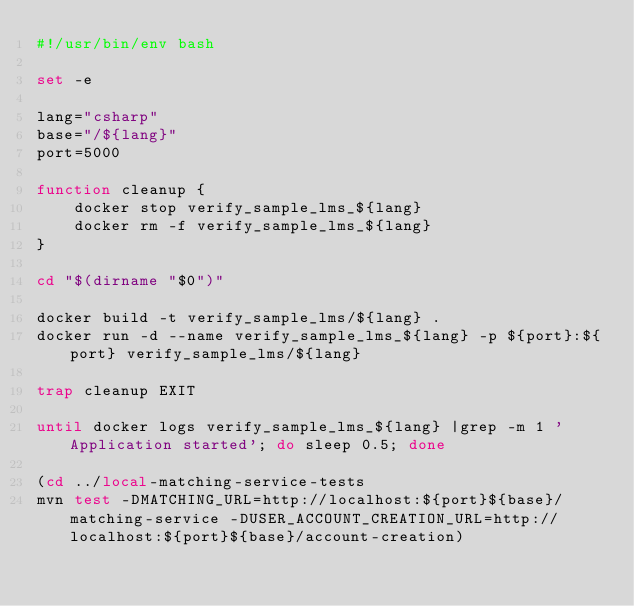Convert code to text. <code><loc_0><loc_0><loc_500><loc_500><_Bash_>#!/usr/bin/env bash

set -e

lang="csharp"
base="/${lang}"
port=5000

function cleanup {
    docker stop verify_sample_lms_${lang}
    docker rm -f verify_sample_lms_${lang}
}

cd "$(dirname "$0")"

docker build -t verify_sample_lms/${lang} .
docker run -d --name verify_sample_lms_${lang} -p ${port}:${port} verify_sample_lms/${lang}

trap cleanup EXIT

until docker logs verify_sample_lms_${lang} |grep -m 1 'Application started'; do sleep 0.5; done

(cd ../local-matching-service-tests
mvn test -DMATCHING_URL=http://localhost:${port}${base}/matching-service -DUSER_ACCOUNT_CREATION_URL=http://localhost:${port}${base}/account-creation)



</code> 